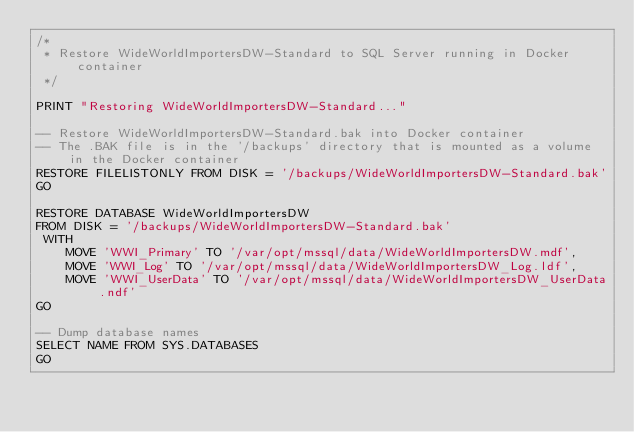Convert code to text. <code><loc_0><loc_0><loc_500><loc_500><_SQL_>/*
 * Restore WideWorldImportersDW-Standard to SQL Server running in Docker container
 */

PRINT "Restoring WideWorldImportersDW-Standard..."

-- Restore WideWorldImportersDW-Standard.bak into Docker container
-- The .BAK file is in the '/backups' directory that is mounted as a volume in the Docker container
RESTORE FILELISTONLY FROM DISK = '/backups/WideWorldImportersDW-Standard.bak'
GO

RESTORE DATABASE WideWorldImportersDW
FROM DISK = '/backups/WideWorldImportersDW-Standard.bak'
 WITH
    MOVE 'WWI_Primary' TO '/var/opt/mssql/data/WideWorldImportersDW.mdf',
    MOVE 'WWI_Log' TO '/var/opt/mssql/data/WideWorldImportersDW_Log.ldf',
    MOVE 'WWI_UserData' TO '/var/opt/mssql/data/WideWorldImportersDW_UserData.ndf'
GO

-- Dump database names
SELECT NAME FROM SYS.DATABASES
GO

</code> 